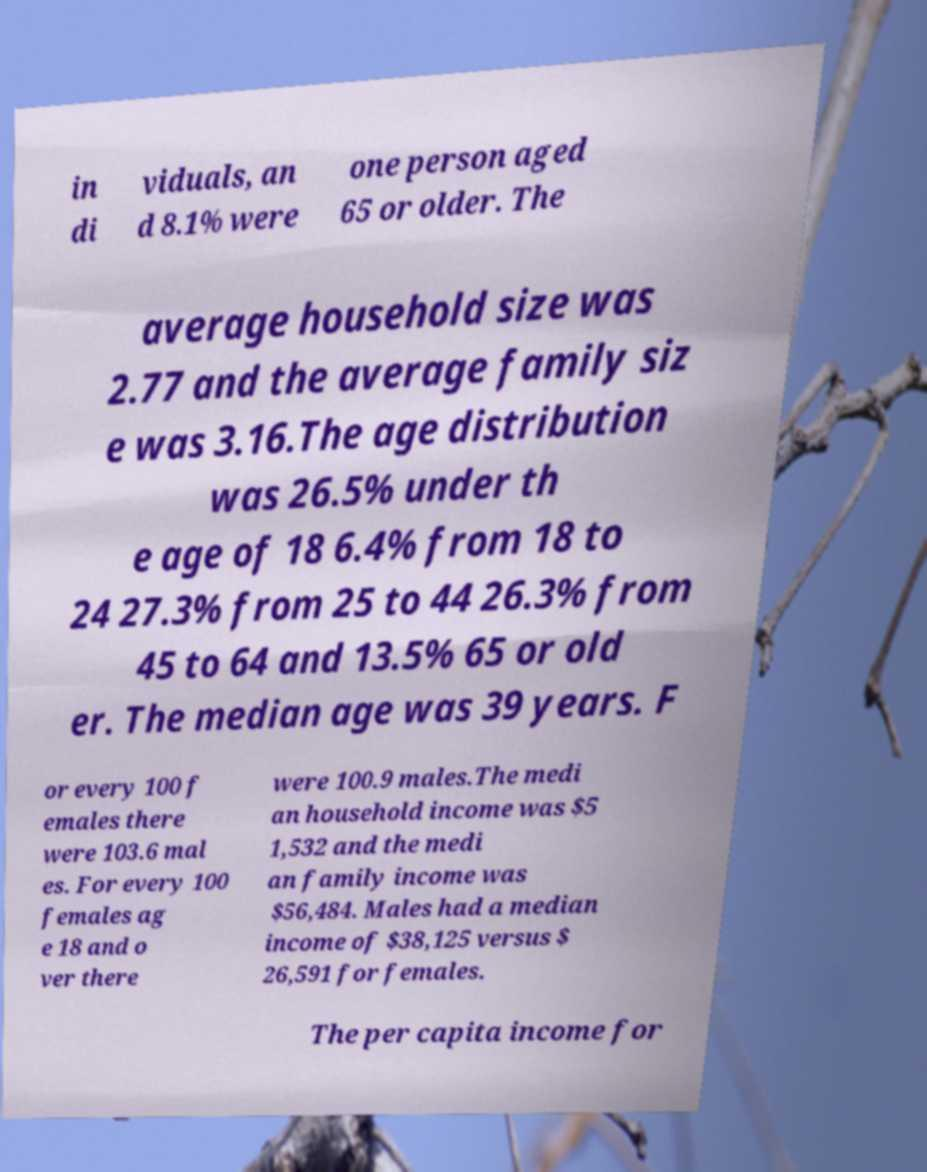What messages or text are displayed in this image? I need them in a readable, typed format. in di viduals, an d 8.1% were one person aged 65 or older. The average household size was 2.77 and the average family siz e was 3.16.The age distribution was 26.5% under th e age of 18 6.4% from 18 to 24 27.3% from 25 to 44 26.3% from 45 to 64 and 13.5% 65 or old er. The median age was 39 years. F or every 100 f emales there were 103.6 mal es. For every 100 females ag e 18 and o ver there were 100.9 males.The medi an household income was $5 1,532 and the medi an family income was $56,484. Males had a median income of $38,125 versus $ 26,591 for females. The per capita income for 